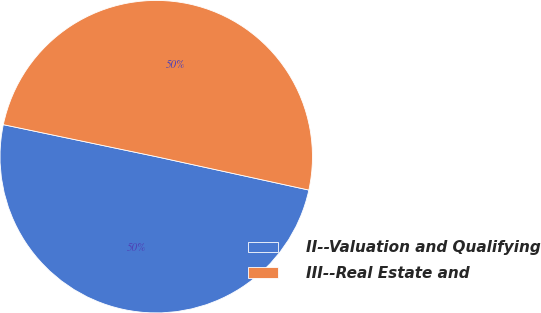Convert chart to OTSL. <chart><loc_0><loc_0><loc_500><loc_500><pie_chart><fcel>II--Valuation and Qualifying<fcel>III--Real Estate and<nl><fcel>49.86%<fcel>50.14%<nl></chart> 